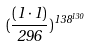<formula> <loc_0><loc_0><loc_500><loc_500>( \frac { ( 1 \cdot 1 ) } { 2 9 6 } ) ^ { 1 3 8 ^ { 1 3 0 } }</formula> 